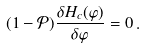<formula> <loc_0><loc_0><loc_500><loc_500>( 1 - \mathcal { P } ) \frac { \delta H _ { c } ( \varphi ) } { \delta \varphi } = 0 \, .</formula> 